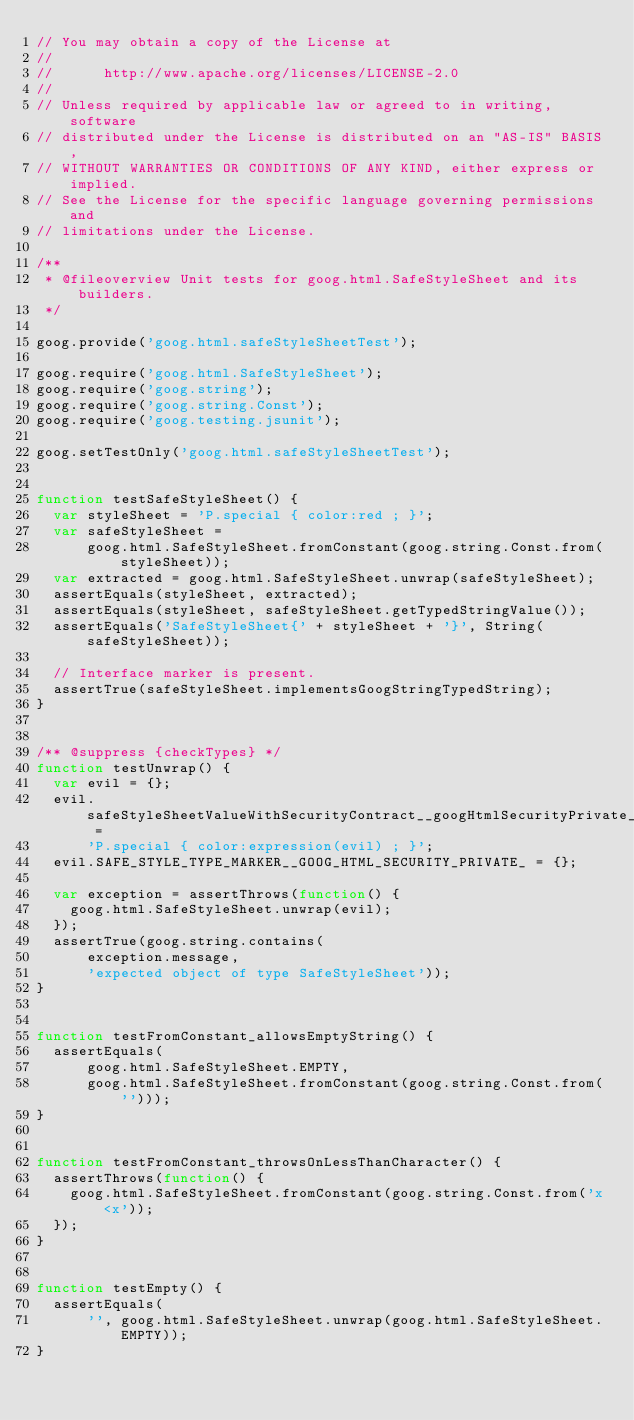Convert code to text. <code><loc_0><loc_0><loc_500><loc_500><_JavaScript_>// You may obtain a copy of the License at
//
//      http://www.apache.org/licenses/LICENSE-2.0
//
// Unless required by applicable law or agreed to in writing, software
// distributed under the License is distributed on an "AS-IS" BASIS,
// WITHOUT WARRANTIES OR CONDITIONS OF ANY KIND, either express or implied.
// See the License for the specific language governing permissions and
// limitations under the License.

/**
 * @fileoverview Unit tests for goog.html.SafeStyleSheet and its builders.
 */

goog.provide('goog.html.safeStyleSheetTest');

goog.require('goog.html.SafeStyleSheet');
goog.require('goog.string');
goog.require('goog.string.Const');
goog.require('goog.testing.jsunit');

goog.setTestOnly('goog.html.safeStyleSheetTest');


function testSafeStyleSheet() {
  var styleSheet = 'P.special { color:red ; }';
  var safeStyleSheet =
      goog.html.SafeStyleSheet.fromConstant(goog.string.Const.from(styleSheet));
  var extracted = goog.html.SafeStyleSheet.unwrap(safeStyleSheet);
  assertEquals(styleSheet, extracted);
  assertEquals(styleSheet, safeStyleSheet.getTypedStringValue());
  assertEquals('SafeStyleSheet{' + styleSheet + '}', String(safeStyleSheet));

  // Interface marker is present.
  assertTrue(safeStyleSheet.implementsGoogStringTypedString);
}


/** @suppress {checkTypes} */
function testUnwrap() {
  var evil = {};
  evil.safeStyleSheetValueWithSecurityContract__googHtmlSecurityPrivate_ =
      'P.special { color:expression(evil) ; }';
  evil.SAFE_STYLE_TYPE_MARKER__GOOG_HTML_SECURITY_PRIVATE_ = {};

  var exception = assertThrows(function() {
    goog.html.SafeStyleSheet.unwrap(evil);
  });
  assertTrue(goog.string.contains(
      exception.message,
      'expected object of type SafeStyleSheet'));
}


function testFromConstant_allowsEmptyString() {
  assertEquals(
      goog.html.SafeStyleSheet.EMPTY,
      goog.html.SafeStyleSheet.fromConstant(goog.string.Const.from('')));
}


function testFromConstant_throwsOnLessThanCharacter() {
  assertThrows(function() {
    goog.html.SafeStyleSheet.fromConstant(goog.string.Const.from('x<x'));
  });
}


function testEmpty() {
  assertEquals(
      '', goog.html.SafeStyleSheet.unwrap(goog.html.SafeStyleSheet.EMPTY));
}
</code> 